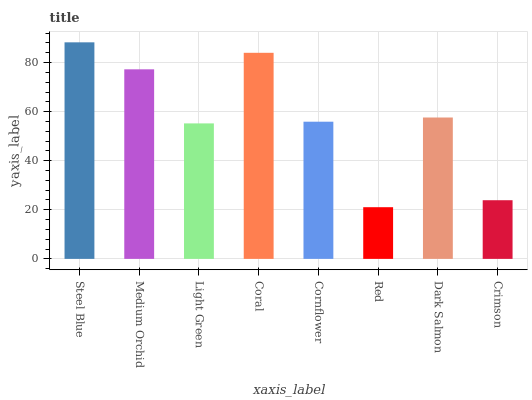Is Red the minimum?
Answer yes or no. Yes. Is Steel Blue the maximum?
Answer yes or no. Yes. Is Medium Orchid the minimum?
Answer yes or no. No. Is Medium Orchid the maximum?
Answer yes or no. No. Is Steel Blue greater than Medium Orchid?
Answer yes or no. Yes. Is Medium Orchid less than Steel Blue?
Answer yes or no. Yes. Is Medium Orchid greater than Steel Blue?
Answer yes or no. No. Is Steel Blue less than Medium Orchid?
Answer yes or no. No. Is Dark Salmon the high median?
Answer yes or no. Yes. Is Cornflower the low median?
Answer yes or no. Yes. Is Red the high median?
Answer yes or no. No. Is Steel Blue the low median?
Answer yes or no. No. 